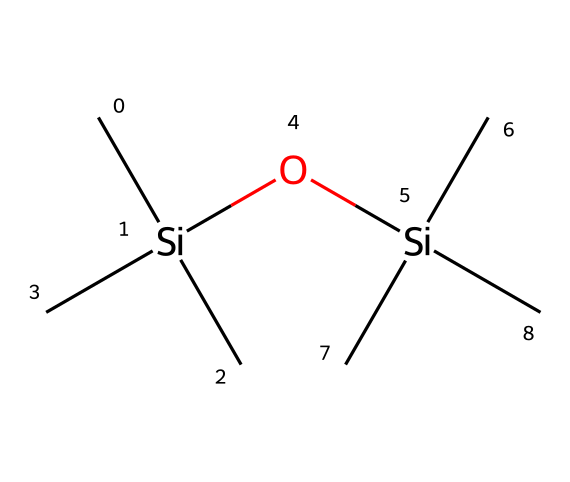how many silicon atoms are present in the chemical structure? The SMILES representation indicates there are two silicon atoms, as we can see [Si] appears twice.
Answer: two what functional group is present in this silane? The presence of the -O- group in the structure indicates that this silane contains a siloxane function.
Answer: siloxane what is the total number of carbon atoms in the chemical? From the chemical structure, counting the 'C' symbols shows there are six carbon atoms in total.
Answer: six how many branches does the silane have? Each silicon atom is connected to three carbon atoms, indicating that there are three branches from each silicon, resulting in a total of six branches.
Answer: six what type of bonding is predominantly observed in this chemical? The structure primarily showcases sigma bonds, as seen in the connections between silicon and carbon atoms, and silicon-oxygen bonds as well.
Answer: sigma bonds what is the main purpose of using such silane-based coatings in agriculture? Silane-based coatings can enhance moisture retention and reduce spoilage, thus extending the shelf life of produce.
Answer: shelf life extension how does the arrangement of silicon and carbon affect the coating properties? The branched structure allows for increased surface area and better adhesion, which can improve the coating's effectiveness on unique vegetables.
Answer: improved adhesion 